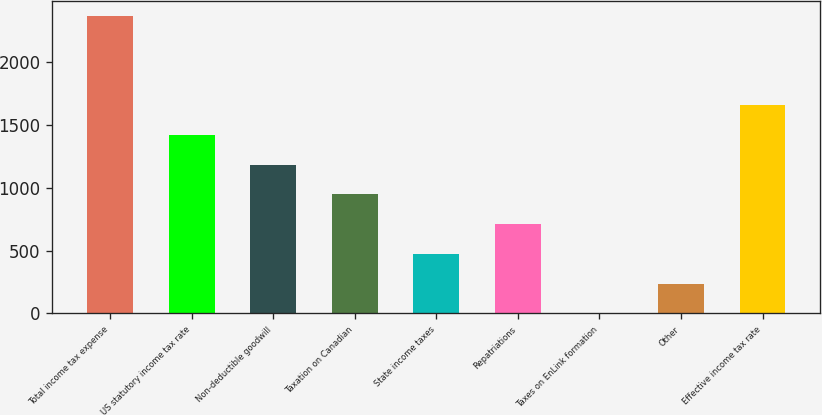Convert chart to OTSL. <chart><loc_0><loc_0><loc_500><loc_500><bar_chart><fcel>Total income tax expense<fcel>US statutory income tax rate<fcel>Non-deductible goodwill<fcel>Taxation on Canadian<fcel>State income taxes<fcel>Repatriations<fcel>Taxes on EnLink formation<fcel>Other<fcel>Effective income tax rate<nl><fcel>2368<fcel>1421.2<fcel>1184.5<fcel>947.8<fcel>474.4<fcel>711.1<fcel>1<fcel>237.7<fcel>1657.9<nl></chart> 